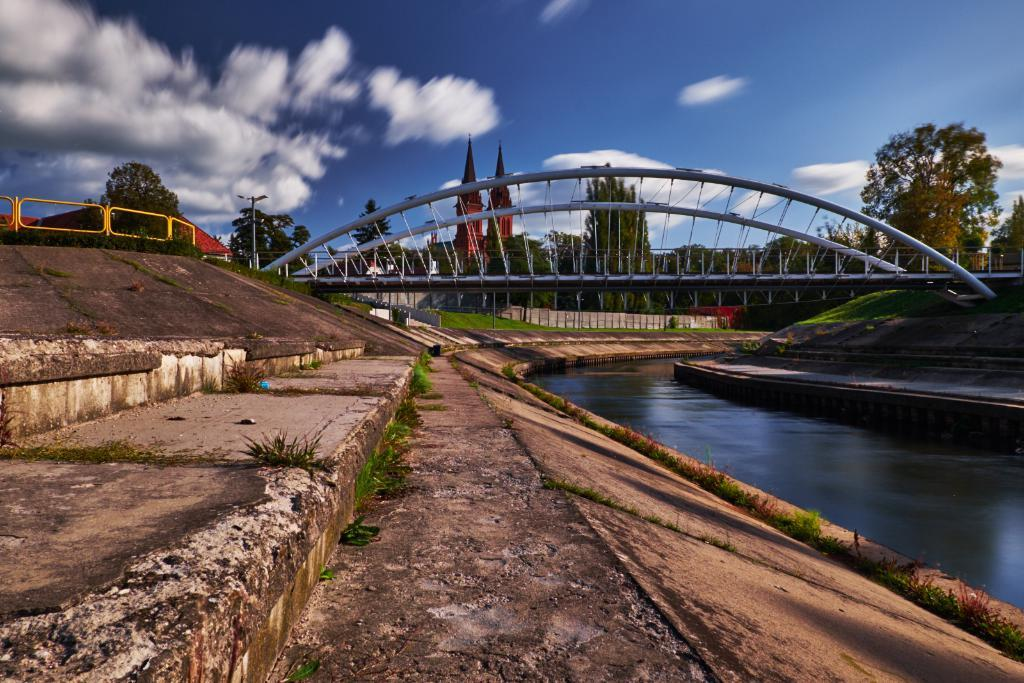What type of water body is shown in the image? The image depicts a canal. Can you describe the water in the image? There is water visible in the image. What type of structure is present for pedestrians to cross the canal? There is a foot over bridge in the image. What other structures can be seen in the image? Poles and fences are visible in the image. What can be seen in the background of the image? There are trees, buildings, and light poles visible in the background of the image. What is the condition of the sky in the image? Clouds are visible in the sky. What method of teaching is being demonstrated in the image? There is no teaching activity present in the image; it depicts a canal with various structures and background elements. What type of vein is visible in the image? There are no veins visible in the image; it features a canal, water, and various structures and background elements. 